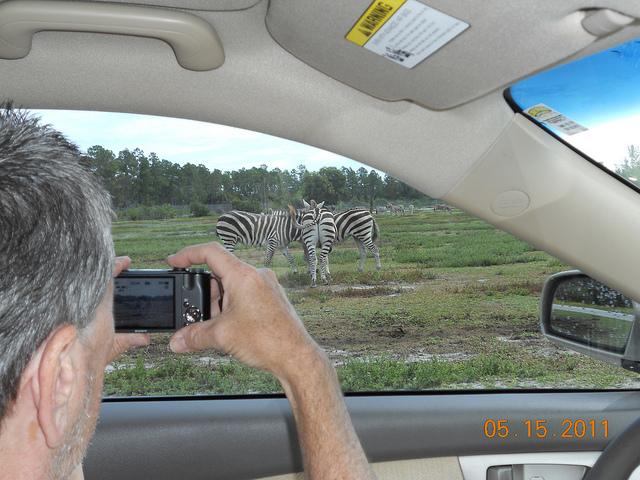How many zebras are there?
Answer briefly. 3. What is the man taking a picture of?
Quick response, please. Zebras. Do the zebras appear to be startled by the car and man?
Write a very short answer. No. What is the man holding?
Concise answer only. Camera. 